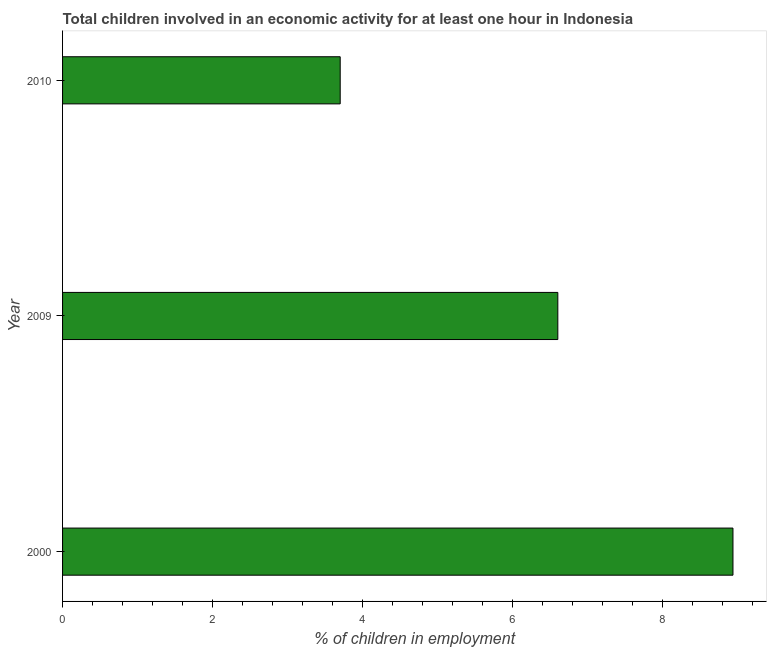What is the title of the graph?
Offer a very short reply. Total children involved in an economic activity for at least one hour in Indonesia. What is the label or title of the X-axis?
Ensure brevity in your answer.  % of children in employment. What is the label or title of the Y-axis?
Ensure brevity in your answer.  Year. What is the percentage of children in employment in 2000?
Ensure brevity in your answer.  8.93. Across all years, what is the maximum percentage of children in employment?
Keep it short and to the point. 8.93. Across all years, what is the minimum percentage of children in employment?
Keep it short and to the point. 3.7. What is the sum of the percentage of children in employment?
Make the answer very short. 19.23. What is the difference between the percentage of children in employment in 2000 and 2009?
Ensure brevity in your answer.  2.33. What is the average percentage of children in employment per year?
Make the answer very short. 6.41. In how many years, is the percentage of children in employment greater than 3.6 %?
Keep it short and to the point. 3. What is the ratio of the percentage of children in employment in 2009 to that in 2010?
Provide a succinct answer. 1.78. Is the difference between the percentage of children in employment in 2000 and 2010 greater than the difference between any two years?
Offer a terse response. Yes. What is the difference between the highest and the second highest percentage of children in employment?
Offer a very short reply. 2.33. What is the difference between the highest and the lowest percentage of children in employment?
Give a very brief answer. 5.23. In how many years, is the percentage of children in employment greater than the average percentage of children in employment taken over all years?
Provide a short and direct response. 2. What is the difference between two consecutive major ticks on the X-axis?
Offer a terse response. 2. Are the values on the major ticks of X-axis written in scientific E-notation?
Offer a terse response. No. What is the % of children in employment of 2000?
Your response must be concise. 8.93. What is the % of children in employment in 2009?
Provide a succinct answer. 6.6. What is the difference between the % of children in employment in 2000 and 2009?
Provide a succinct answer. 2.33. What is the difference between the % of children in employment in 2000 and 2010?
Provide a succinct answer. 5.23. What is the difference between the % of children in employment in 2009 and 2010?
Offer a terse response. 2.9. What is the ratio of the % of children in employment in 2000 to that in 2009?
Keep it short and to the point. 1.35. What is the ratio of the % of children in employment in 2000 to that in 2010?
Keep it short and to the point. 2.42. What is the ratio of the % of children in employment in 2009 to that in 2010?
Make the answer very short. 1.78. 